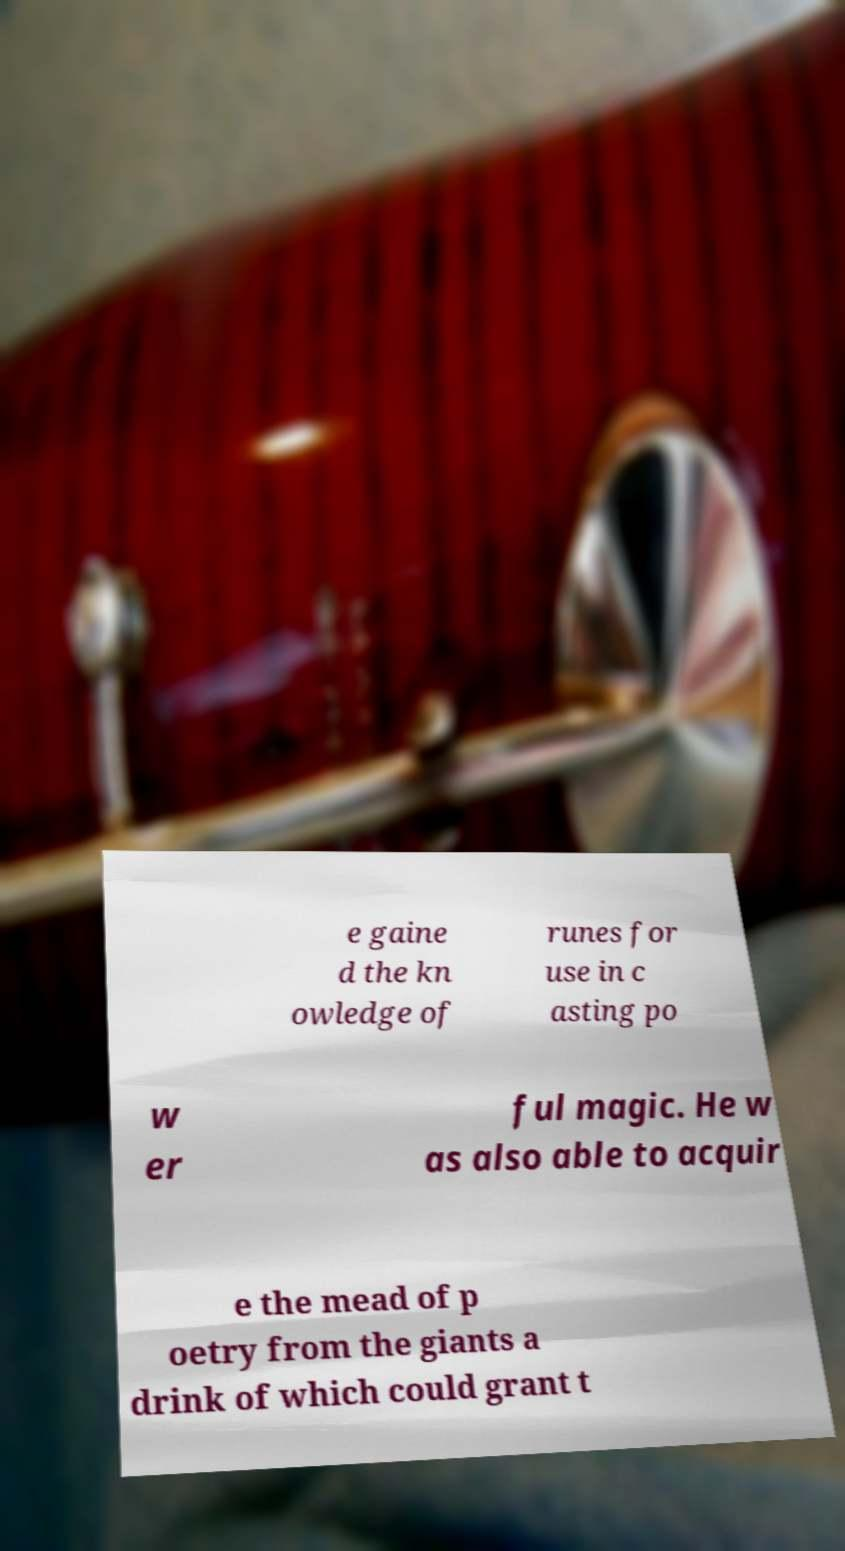I need the written content from this picture converted into text. Can you do that? e gaine d the kn owledge of runes for use in c asting po w er ful magic. He w as also able to acquir e the mead of p oetry from the giants a drink of which could grant t 